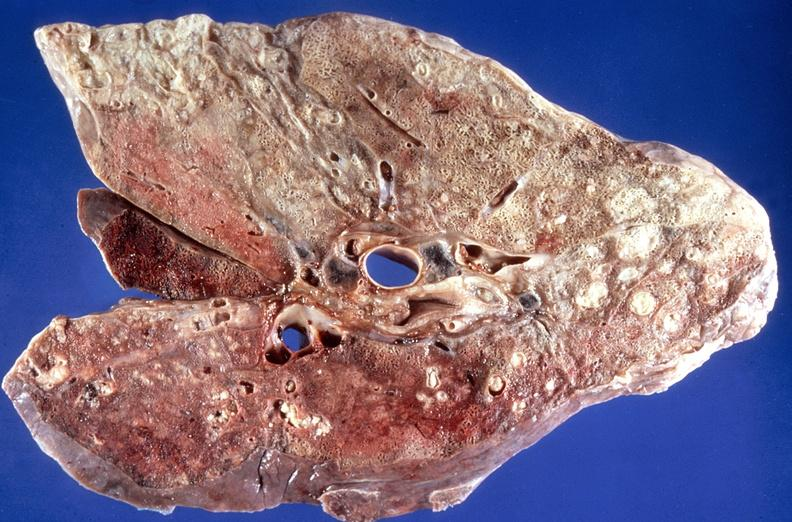does this image show lung, bronchopneumonia, cystic fibrosis?
Answer the question using a single word or phrase. Yes 